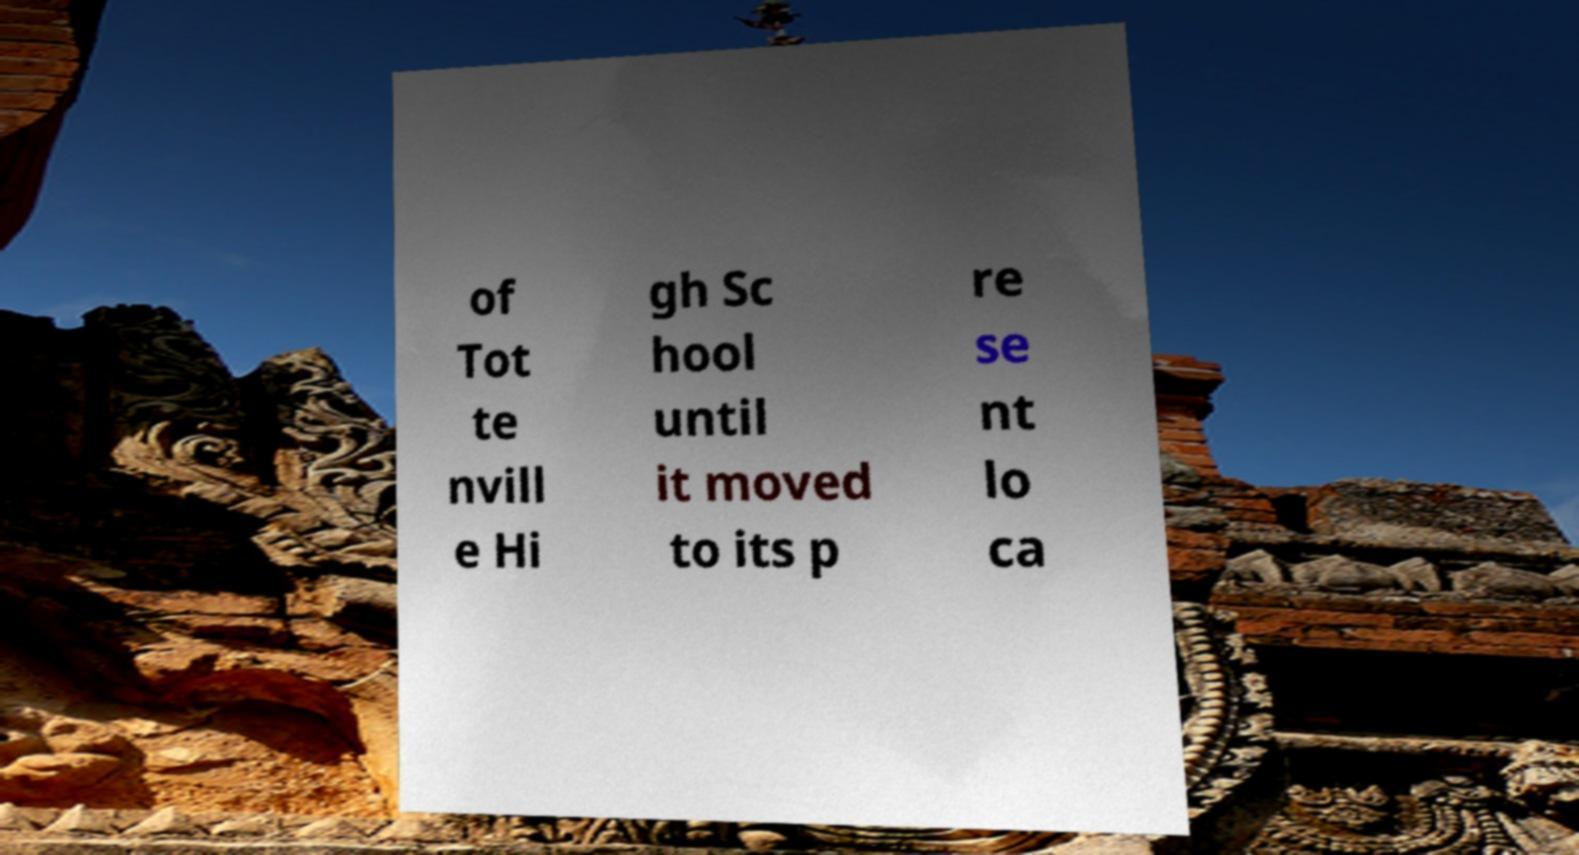Can you accurately transcribe the text from the provided image for me? of Tot te nvill e Hi gh Sc hool until it moved to its p re se nt lo ca 